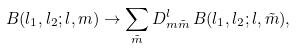<formula> <loc_0><loc_0><loc_500><loc_500>B ( l _ { 1 } , l _ { 2 } ; l , m ) \to \sum _ { \tilde { m } } D ^ { l } _ { m \tilde { m } } \, B ( l _ { 1 } , l _ { 2 } ; l , \tilde { m } ) ,</formula> 